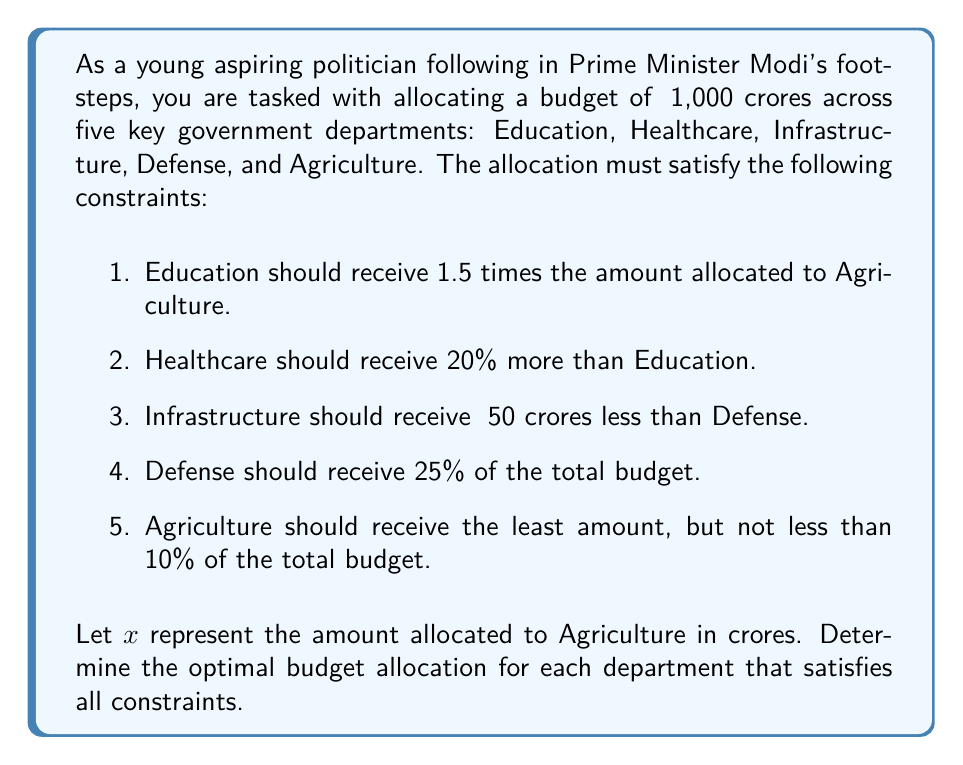Teach me how to tackle this problem. Let's solve this step-by-step using the given constraints:

1. Define variables:
   Agriculture: $x$
   Education: $1.5x$
   Healthcare: $1.5x + 0.2(1.5x) = 1.8x$
   Defense: $0.25(1000) = 250$ (25% of total budget)
   Infrastructure: $250 - 50 = 200$ (₹50 crores less than Defense)

2. Set up the equation based on the total budget:
   $$x + 1.5x + 1.8x + 250 + 200 = 1000$$

3. Simplify the equation:
   $$4.3x + 450 = 1000$$

4. Solve for $x$:
   $$4.3x = 550$$
   $$x = \frac{550}{4.3} \approx 127.91$$

5. Round $x$ to the nearest whole number:
   Agriculture: $x = 128$ crores

6. Calculate the allocations for other departments:
   Education: $1.5x = 1.5(128) = 192$ crores
   Healthcare: $1.8x = 1.8(128) = 230.4 \approx 230$ crores
   Defense: 250 crores (already given)
   Infrastructure: 200 crores (already calculated)

7. Verify that Agriculture receives at least 10% of the total budget:
   $128 \div 1000 = 0.128 = 12.8\%$, which satisfies the constraint.

8. Verify that the total allocation equals the budget:
   $128 + 192 + 230 + 250 + 200 = 1000$ crores
Answer: The optimal budget allocation:
Agriculture: ₹128 crores
Education: ₹192 crores
Healthcare: ₹230 crores
Defense: ₹250 crores
Infrastructure: ₹200 crores 